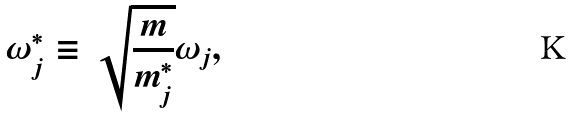<formula> <loc_0><loc_0><loc_500><loc_500>\omega _ { j } ^ { * } \equiv \sqrt { \frac { m } { m _ { j } ^ { * } } } \omega _ { j } ,</formula> 